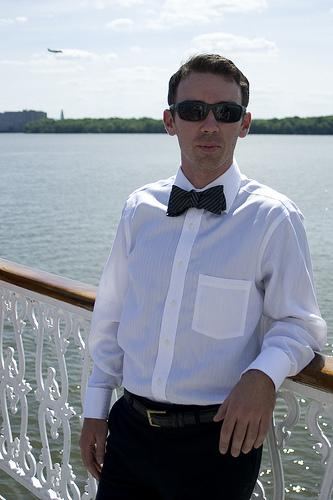Are there any natural formations visible in the image? If so, describe them. Yes, there is a blue sky with clouds and a long row of green trees in the background. What is the man wearing around his waist in the image? The man is wearing a black belt with a gold clasp around his waist. Describe the type of shirt the man is wearing in the photograph. The man is wearing a white and gray pinstripe button down shirt. What is the man in the image wearing on his face? The man is wearing black dark tinted sunglasses on his face. What is the setting of the image, and where is the man standing? The setting is a boat deck overlooking the ocean, and the man is standing near a guard rail by the river. Identify the type of pants worn by the man in the picture. The man is wearing black slacks. Highlight an attribute of the man's hair in the photograph. The man has brown hair. What type of tie is the man in the image wearing? The man is wearing a black and white pinstripe bow tie. What type of vehicle is seen in the sky in the image? A small gray airplane is seen flying in the sky. Does the man wear a belt, and if so, what is the color and design of the belt's buckle? Yes, he wears a black belt with a gold clasp. Identify the type of attire the man is wearing and mention a detail about his bowtie. Formal attire and black and white striped bowtie Identify the object flying in the sky and describe its color. Small gray airplane Can you locate the yellow umbrella near the man wearing a white shirt? Make sure to notice the unique pattern on the umbrella. There is no mention of a yellow umbrella or any umbrella for that matter in the image captions. This instruction is misleading as it asks the user to look for something that doesn't exist in the image. What type of accessory does the man wear on his face? Black sunglasses Identify the location where the man is standing. On a boat deck Please identify the cute dog playing with the man wearing formal attire, and describe the dog's fur color and pattern. No information about any dog or animals is present in the image captions. The instruction is misleading because it introduces an entirely new subject (a dog) that's not part of the image. What is unusual about the man's appearance? He is wearing black sunglasses and formal attire on a boat. Describe the nature of the event depicted in the image. A man dressed in formal attire on a boat, enjoying a day on the ocean with a small airplane flying nearby List the key elements of the man's outfit, including clothing and accessories. Pinstriped white shirt, black pants, black and white bowtie, black sunglasses, black belt with gold clasp Determine if the image shows the ocean or a lake. Ocean What type of shirt does the man wear? Pinstriped white shirt What can be seen flying near the ocean in the image? A small gray airplane Could you point out the large body of water that the man is standing in front of? Mention its characteristics and whether it's a lake, river, or ocean. The image captions do not mention any body of water, such as a lake, river, or ocean. This instruction is misleading because it adds new, non-existent scenery elements to the image. Could you count and report the number of birds flying in the sky, alongside the airplane in the image? Please also describe their sizes and flight pattern. The image captions do not include any information about birds present in the sky. This instruction is misleading because it introduces new elements (birds) to the image's content. Describe whether the man's expression is happy, sad, or neutral. Neutral What is the color of the bowtie worn by the man? Black and white Can you see the details on the man's finger? Yes, the finger nail of a man is visible. What facial feature was used to determine the man's mood? The mouth of the man Locate the woman wearing a red dress standing beside the man with a bowtie, and describe the style of her dress. No mention of a woman or a red dress can be found in the image captions. This instruction is misleading since it attempts to add a new character (the woman) in the scene who is not present in the image. What is the most striking feature of the man's face? He wears black, dark-tinted sunglasses Select the correct description of the man's outfit. b) Wearing a pinstriped white shirt, black pants, and a black and white bowtie Write a caption that includes the man's attire, the setting, and the flying object in the sky. A man dressed in formal attire standing on a boat deck with a small airplane flying in the sky Find the table with a bottle of champagne and two glasses next to the man wearing the pinstriped shirt. What color is the tablecloth and are the glasses empty or full? No, it's not mentioned in the image. Describe the view from the boat. Ocean with a blue sky, clouds, green trees, and a tall dark building on the horizon 